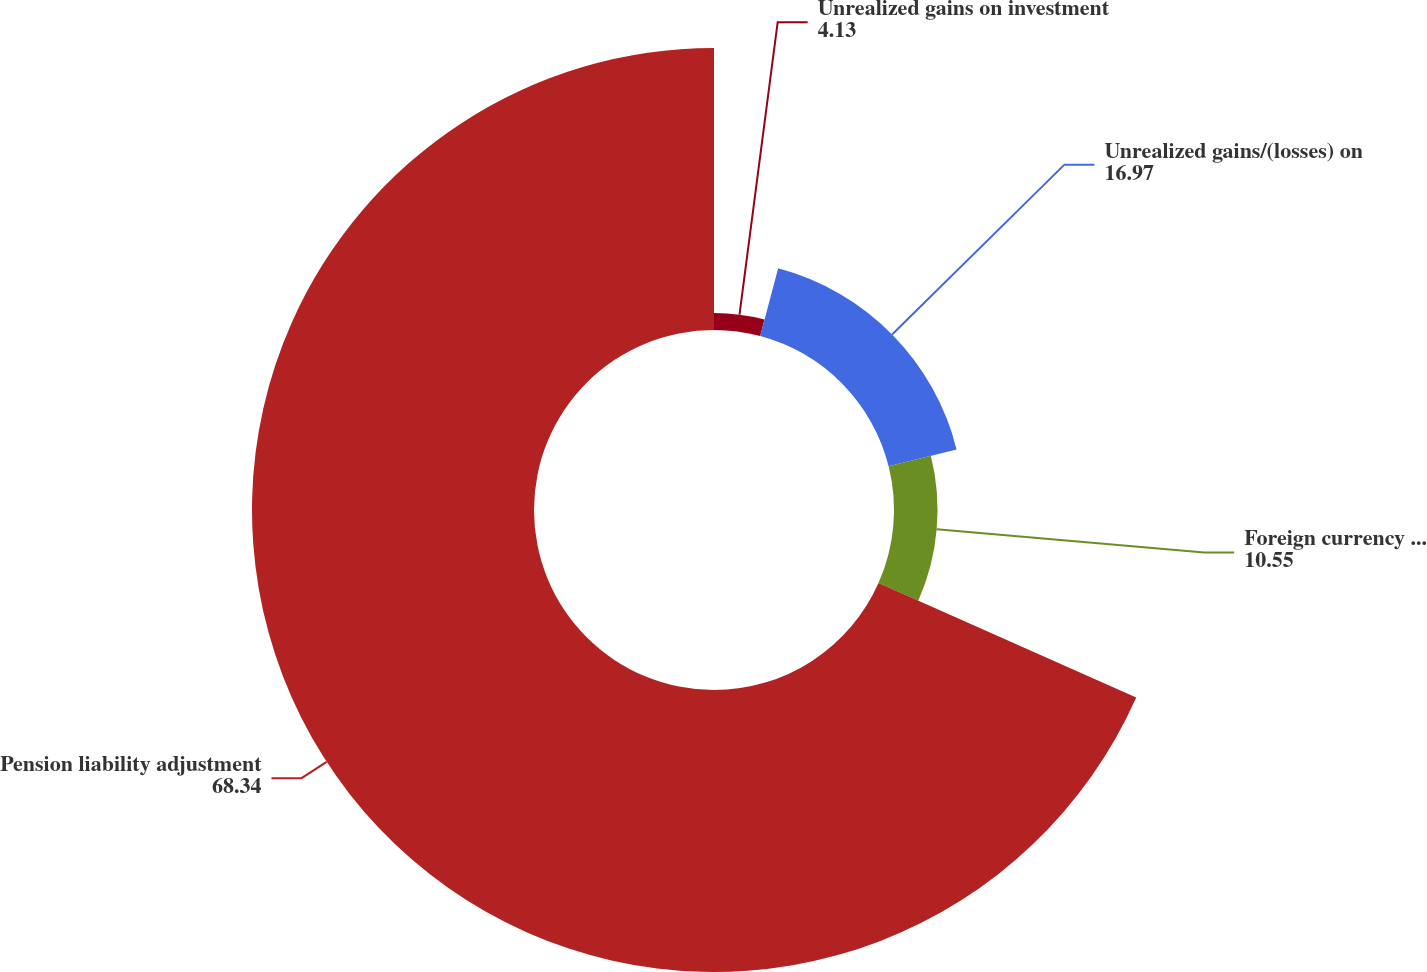Convert chart. <chart><loc_0><loc_0><loc_500><loc_500><pie_chart><fcel>Unrealized gains on investment<fcel>Unrealized gains/(losses) on<fcel>Foreign currency translation<fcel>Pension liability adjustment<nl><fcel>4.13%<fcel>16.97%<fcel>10.55%<fcel>68.34%<nl></chart> 